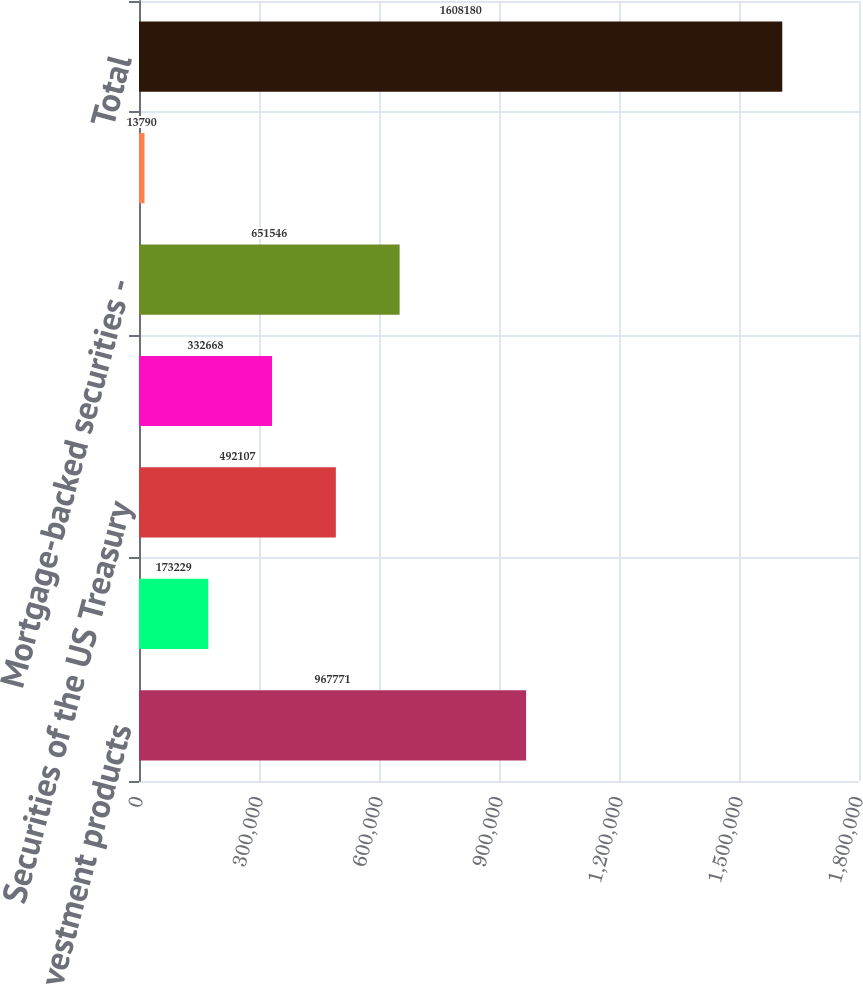Convert chart to OTSL. <chart><loc_0><loc_0><loc_500><loc_500><bar_chart><fcel>Sponsored investment products<fcel>Securities of US states and<fcel>Securities of the US Treasury<fcel>Corporate debt securities<fcel>Mortgage-backed securities -<fcel>Other equity securities<fcel>Total<nl><fcel>967771<fcel>173229<fcel>492107<fcel>332668<fcel>651546<fcel>13790<fcel>1.60818e+06<nl></chart> 